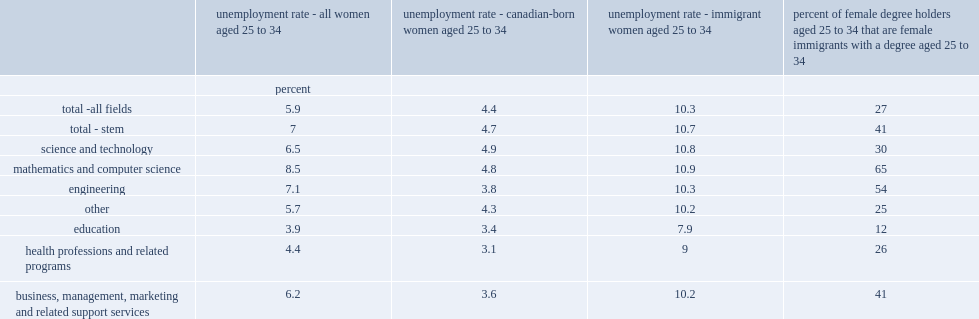What was the unemployment rate of young canadian-born women aged 25 to 34 with a stem degree? 4.7. What was the unemployment rate of young canadian-born women aged 25 to 34 with a non-stem degree? 4.3. Under which condition was the unemployment rate of young canadian-born women aged 25 to 64 higher than the other, women with a stem degree or with a non-stem degree? Total - stem. What was the unemployment rate of young immigration women with stem degrees? 10.7. What was the unemployment rate of young immigration women with non-stem degrees? 10.2. Which type of young immigrant women was more likely to be unemployed? Total - stem. What was the proportion of immigrant women that were young female stem degree holders? 41.0. What was the proportion of immigrant women that were young female non-stem degree holders? 25.0. Which type of young female took a larger proportion in immigrant women, female with stem degree or without stem degree? Total - stem. What was the unemployment rate of young female canadian-born engineering degree holders among the stem fields? 3.8. What was the unemployment rate of young female canadian-born mathematics and computer science degree holders among the stem fields? 4.8. What was the unemployment rate of young female canadian-born science and technology degree holders among the stem fields? 4.9. Which type of canadian-born young female had the highest unemployment rate? Science and technology. What was the unemployment rate of young female canadian-born women that had degrees in business, management, marketing and related support services? 3.6. What was the unemployment rate of young female canadian-born women that had degrees in health and related programs? 3.1. What was the unemployment rate of young female canadian-born women that had degrees in education? 3.4. What was the unemployment rate of young female immigrants with a non-stem degree in education? 7.9. What was the unemployment rate of young female immigrants with a non-stem degree in health and related programs? 9.0. What was the unemployment rate of young female immigrants with a non-stem degree in business, management, marketing and related support services? 10.2. 